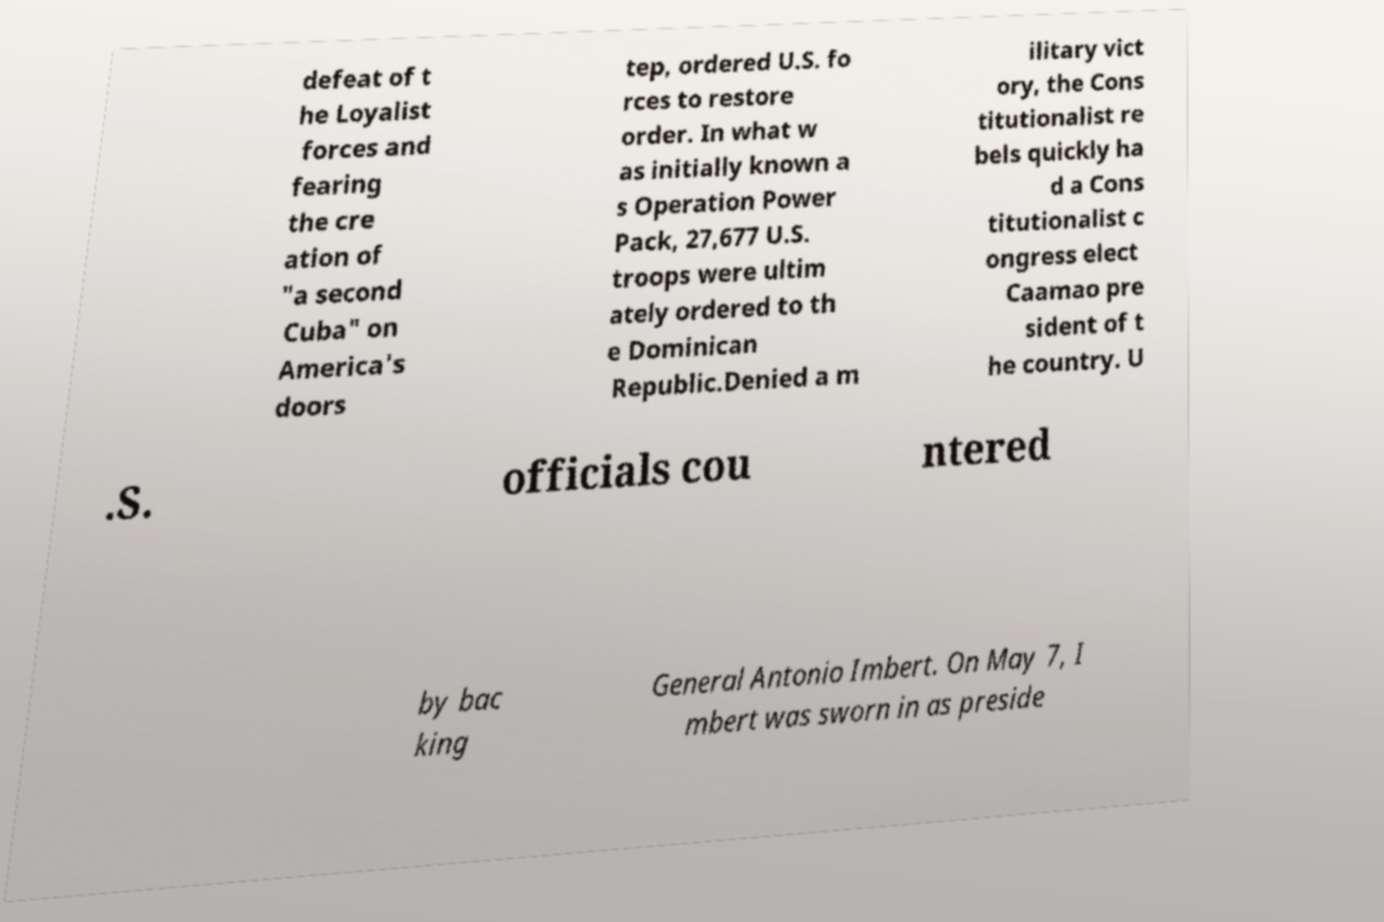Could you assist in decoding the text presented in this image and type it out clearly? defeat of t he Loyalist forces and fearing the cre ation of "a second Cuba" on America's doors tep, ordered U.S. fo rces to restore order. In what w as initially known a s Operation Power Pack, 27,677 U.S. troops were ultim ately ordered to th e Dominican Republic.Denied a m ilitary vict ory, the Cons titutionalist re bels quickly ha d a Cons titutionalist c ongress elect Caamao pre sident of t he country. U .S. officials cou ntered by bac king General Antonio Imbert. On May 7, I mbert was sworn in as preside 